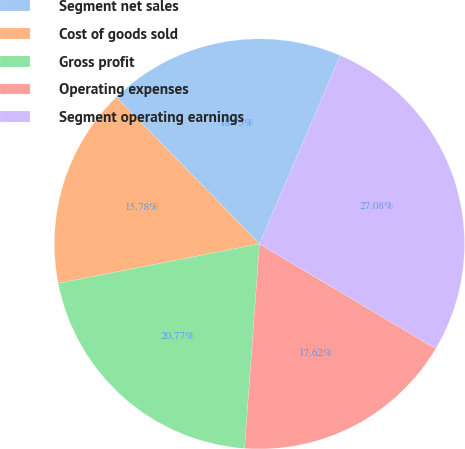Convert chart. <chart><loc_0><loc_0><loc_500><loc_500><pie_chart><fcel>Segment net sales<fcel>Cost of goods sold<fcel>Gross profit<fcel>Operating expenses<fcel>Segment operating earnings<nl><fcel>18.75%<fcel>15.78%<fcel>20.77%<fcel>17.62%<fcel>27.08%<nl></chart> 